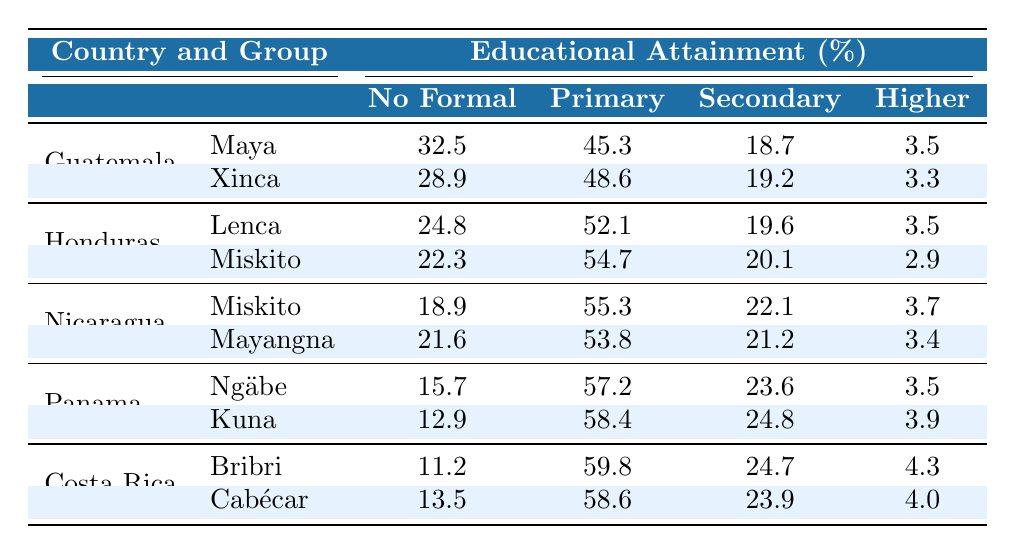What percentage of the Maya group in Guatemala has no formal education? According to the table, the percentage of the Maya group in Guatemala that has no formal education is listed directly as 32.5% in the corresponding row.
Answer: 32.5% Which indigenous group in Honduras has the highest percentage of primary education? The table shows that the Miskito group in Honduras has 54.7% for primary education, which is higher than the Lenca's 52.1%.
Answer: Miskito What is the total percentage of indigenous people in Panama who have either secondary or higher education? For the Ngäbe group in Panama, the percentage of secondary education is 23.6% and higher education is 3.5%. For the Kuna group, secondary is 24.8% and higher is 3.9%. So, sum them up: (23.6 + 3.5) + (24.8 + 3.9) = 55.8%.
Answer: 55.8% Does the data indicate that the indigenous group Kuna has more individuals with higher education compared to the Miskito group in Honduras? For the Kuna group, the percentage of higher education is 3.9%, while for the Miskito group in Honduras, it is 2.9%. Since 3.9% is greater than 2.9%, the statement is true.
Answer: Yes What is the average percentage of no formal education across all groups in Costa Rica? The Bribri group has 11.2% and the Cabécar has 13.5% for no formal education. The average is calculated as (11.2 + 13.5) / 2 = 12.4%.
Answer: 12.4% Which country has the lowest percentage of individuals with no formal education among their indigenous groups? By comparing the lowest percentages of no formal education across countries, Panama has the lowest with 15.7% from the Ngäbe group.
Answer: Panama Which indigenous group has the highest percentage of secondary education overall? Looking at the secondary education percentages, Kuna has 24.8% in Panama, and the other groups have lower percentages. So, the Kuna group has the highest overall.
Answer: Kuna What is the difference in the percentage of higher education between the Maya group and the Lenca group? The Maya group in Guatemala has 3.5% for higher education and the Lenca group in Honduras has 3.5%. The difference is 3.5% - 3.5% = 0%.
Answer: 0% Which country has the average percentages of primary education for its indigenous populations? The primary education percentages are 45.3% for the Maya and 48.6% for the Xinca in Guatemala, 52.1% for Lenca and 54.7% for Miskito in Honduras, 55.3% for Miskito and 53.8% for Mayangna in Nicaragua, and so on. Adding these and dividing by the number of groups (10) gives an average (summed value is  288.4/10) = 28.8%.
Answer: 28.8% Which group has a higher percentage of secondary education: the Maya or the Ngäbe? The Maya has 18.7% for secondary education, and the Ngäbe has 23.6%. Since 23.6% is greater than 18.7%, the Ngäbe has a higher percentage.
Answer: Ngäbe 